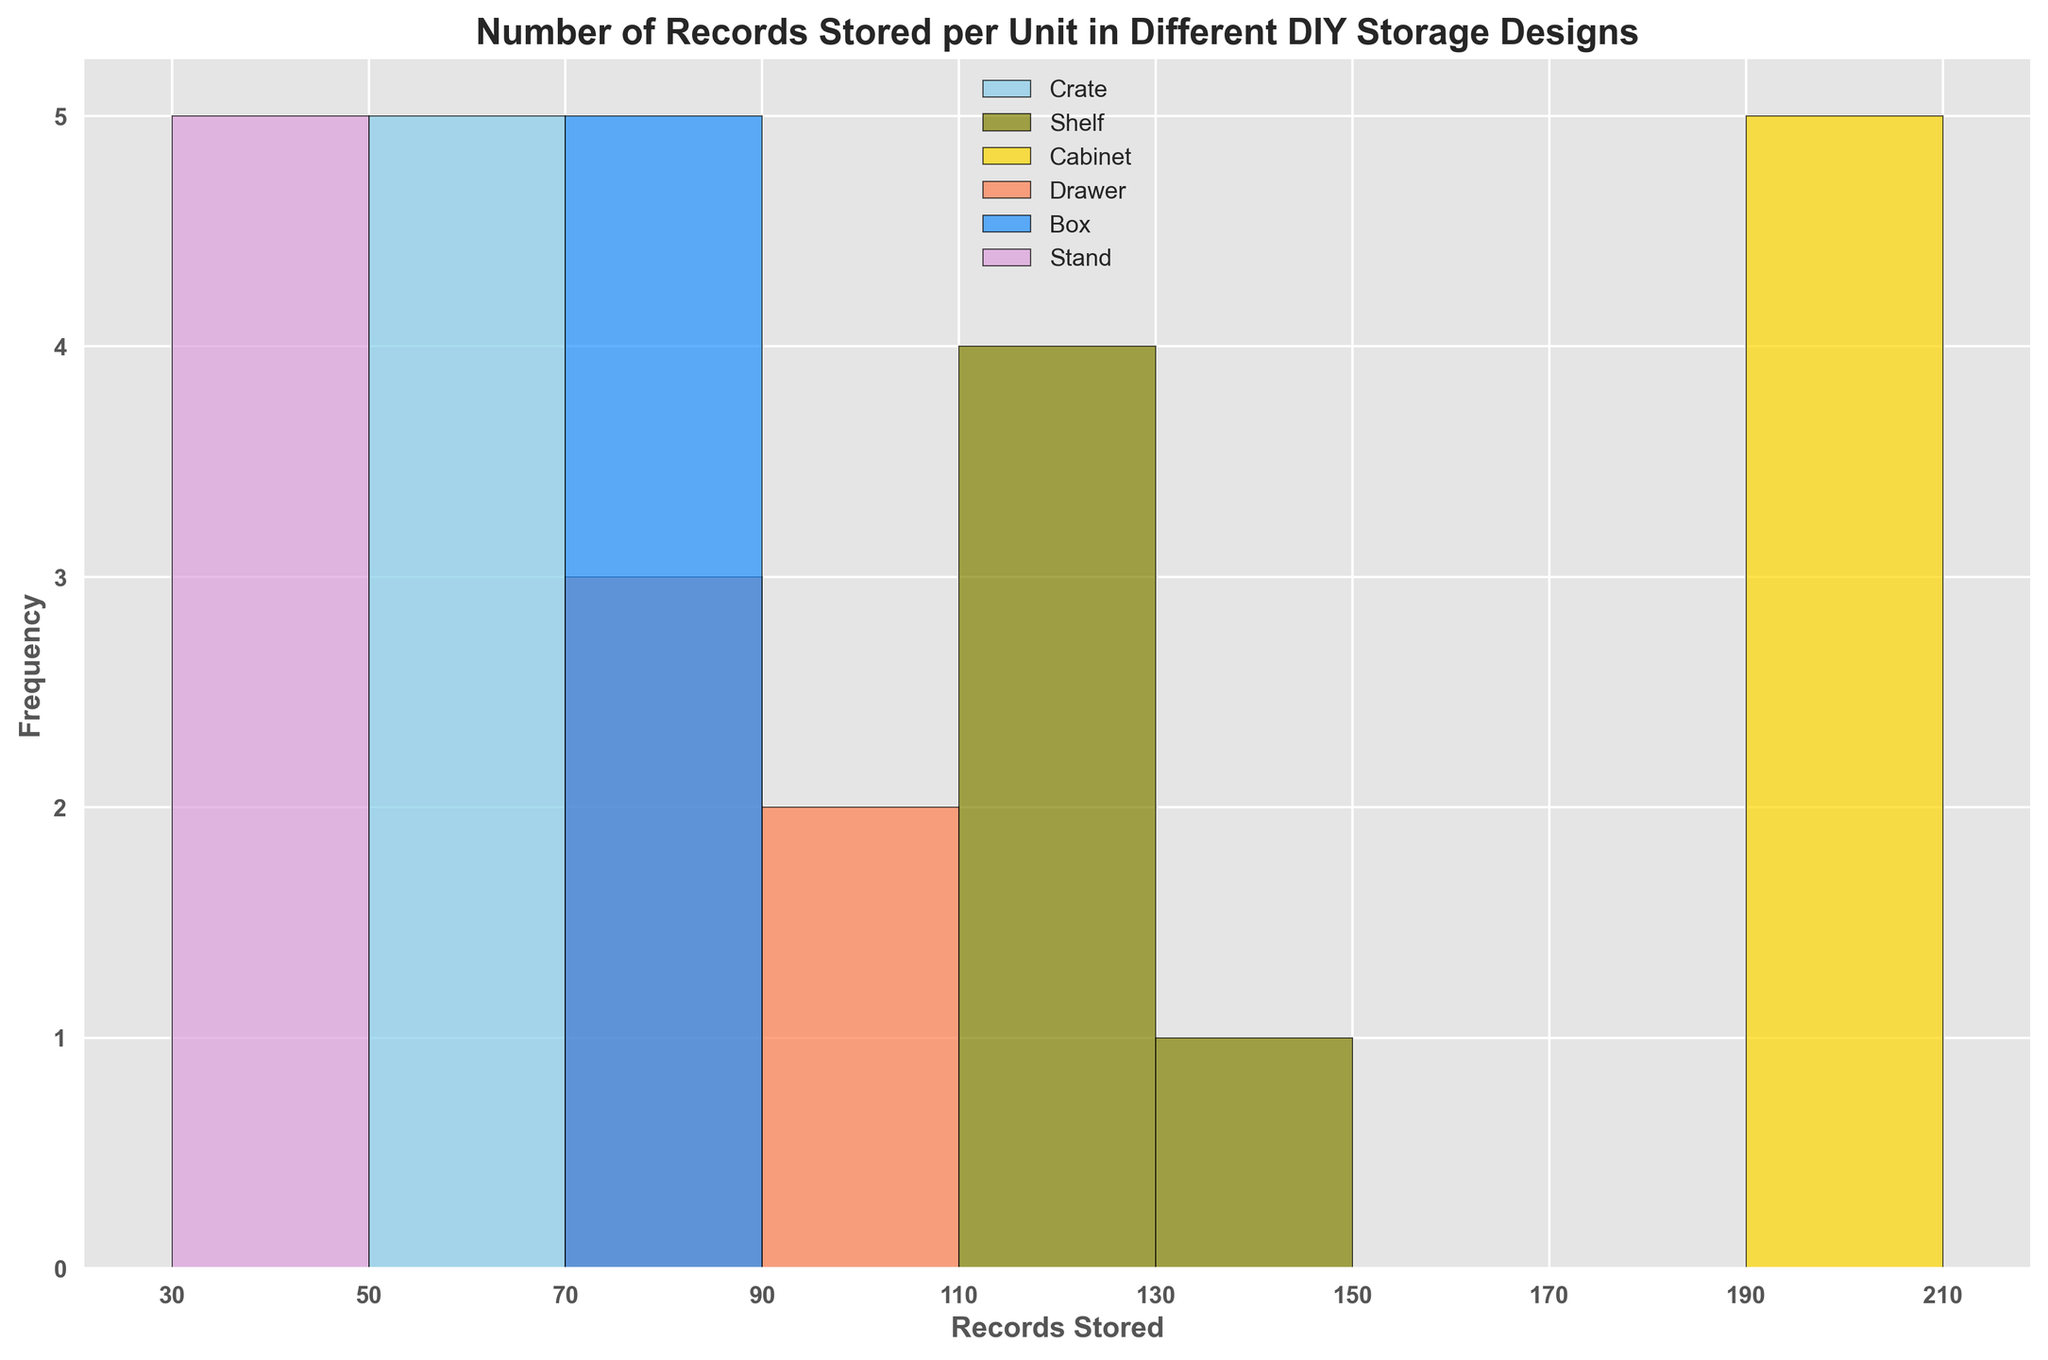How many bins are there in the histogram? First, identify the range of data, which goes from around 30 to 210 records stored. Notice that the bin edges are provided at intervals (30, 50, 70, etc.). Counting these intervals shows there are 9 bins.
Answer: 9 Which storage design stores the fewest records in most cases? Observe the peaks in the histogram for each design. The "Stand" design peaks in the lowest bin (30-40) compared to others that have higher peaks in higher bins.
Answer: Stand How does the distribution of records stored in the "Crate" design compare to the "Box" design? Look at the bins where both "Crate" and "Box" designs have their records stored. The "Crate" design records are concentrated in the 50-60 range, while the "Box" design spans from 70-80.
Answer: Crate is in 50-60; Box is in 70-80 Which design appears to have the most consistent number of records stored per unit? Consistency would be shown by bars of almost the same height in a tight range of bins. The "Shelf" design shows this, as its bins from 110 to 130 have similar heights.
Answer: Shelf Which storage design stores the highest number of records per unit? Look for the highest bin categories and see which design peaks there. "Cabinet" peaks in the bin 200-210, the highest range.
Answer: Cabinet Is there a design that stores records in the 90-110 bin range? Examine the histogram for any design’s bar heights within the bin range of 90-110. There are no designs peaking in this range.
Answer: No What is the most frequent range of records stored for the "Drawer" design? Check the bins where the "Drawer" design's bars are tallest. For "Drawer," the 80-90 range has the highest frequency.
Answer: 80-90 Do any designs share the same color, and how can we differentiate them? Identify the colors used in the chart. Each design uses a unique color: Crate (skyblue), Shelf (olive), Cabinet (gold), Drawer (coral), Box (dodgerblue), and Stand (plum). Since no designs share the same color, differentiation is straightforward.
Answer: No shared colors; unique colors per design Which storage design has a wider range of records stored, "Crate" or "Shelf"? Compare the spread of the bins for both designs. "Crate" spans from 50-60, while "Shelf" spans from 110-130. The range for "Shelf" is 20 units compared to "Crate's" 10 units.
Answer: Shelf What is the bin width used in the histogram? The bin edges show intervals at every 20 records (30, 50, 70, etc.), which indicates the bin width is 20.
Answer: 20 